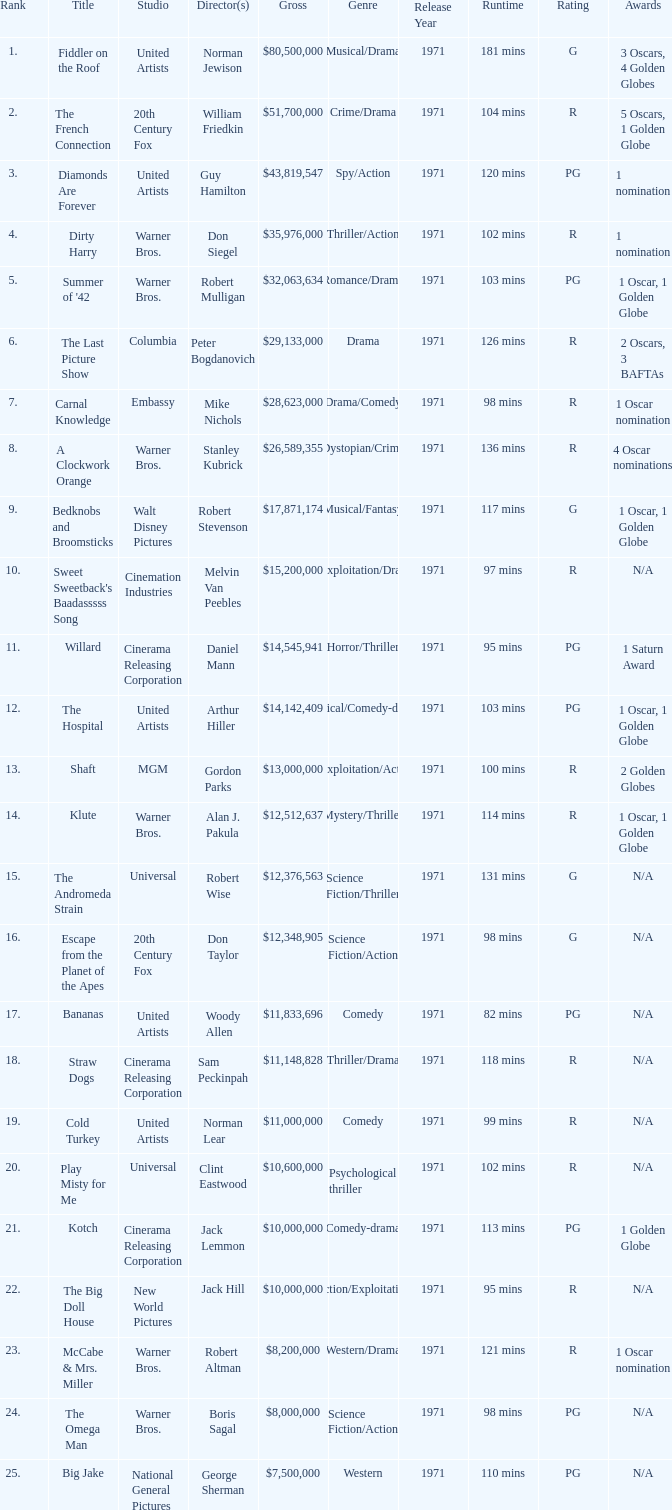What is the rank of The Big Doll House? 22.0. 